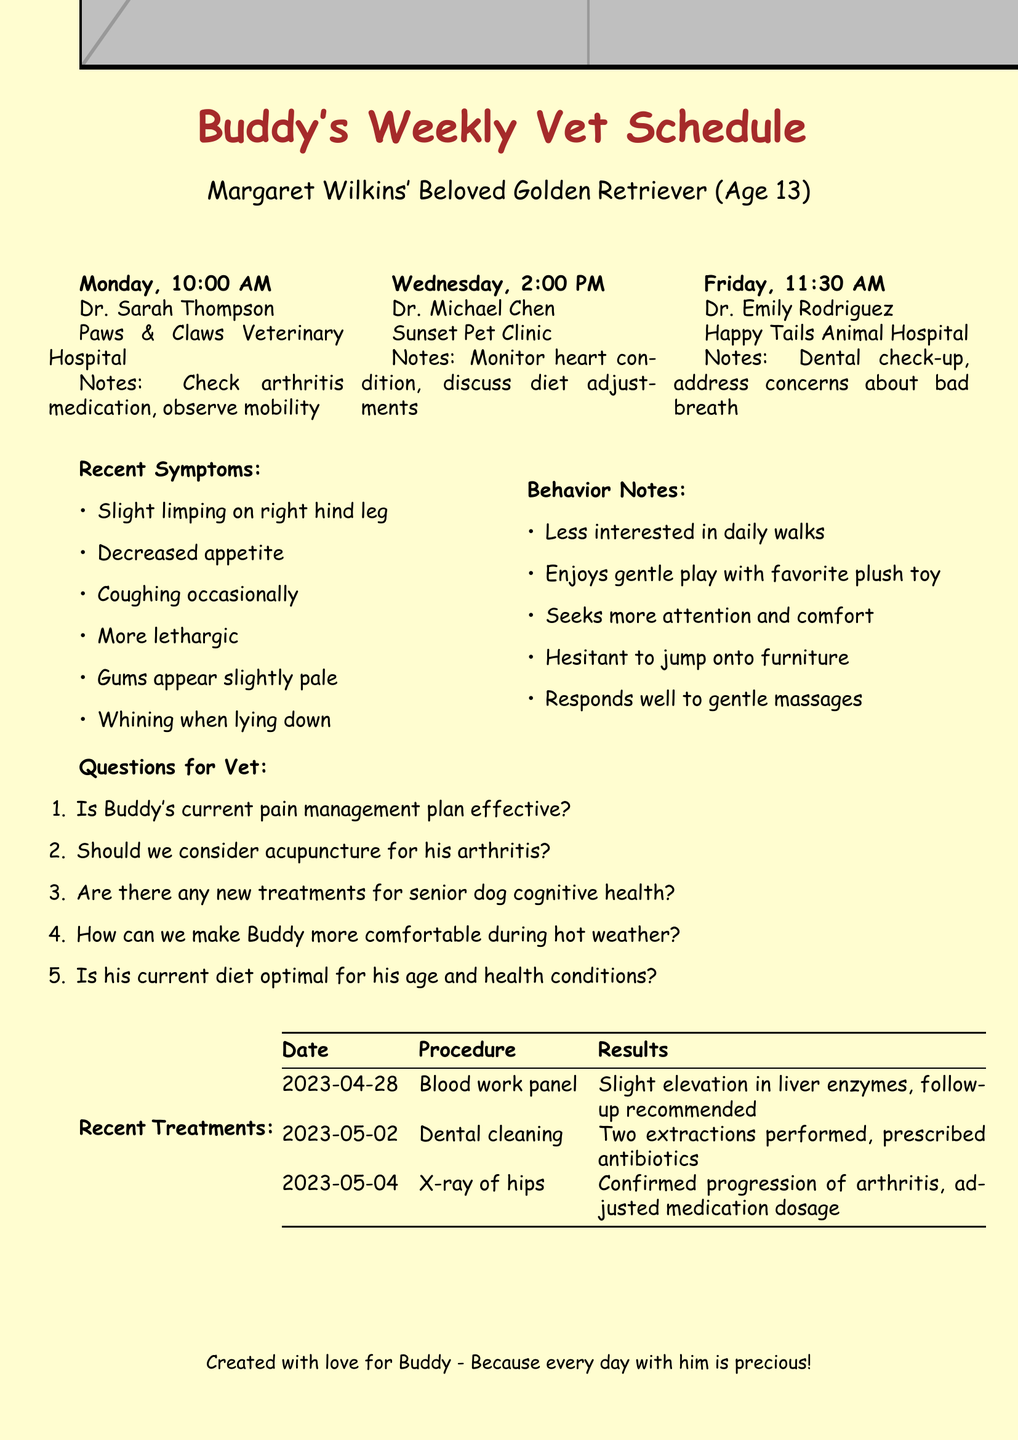what is Buddy's age? Buddy is identified as a 13-year-old dog in the document.
Answer: 13 who is Buddy's vet on Monday? The document states that Dr. Sarah Thompson is the vet scheduled on Monday.
Answer: Dr. Sarah Thompson what time is Buddy's appointment on Wednesday? The document specifies that the appointment on Wednesday is at 2:00 PM.
Answer: 2:00 PM what are the recent symptoms observed on May 5? The document lists several symptoms observed on this date, including slight limping and decreased appetite.
Answer: Gums appear slightly pale, reluctant to climb stairs, whining when lying down how many treatments were noted in the recent treatments section? The document details three recent treatments Buddy has received.
Answer: 3 what recommendation is given following the blood work panel? The document indicates that a follow-up is recommended due to slight elevation in liver enzymes.
Answer: Follow-up recommended what does Buddy enjoy during playtime? According to the behavior notes, Buddy still enjoys gentle play sessions with a favorite plush toy.
Answer: Gentle play sessions with favorite plush toy what is a main concern to address during Friday's appointment? The appointment notes for Friday suggest addressing concerns about Buddy's bad breath.
Answer: Concerns about bad breath 